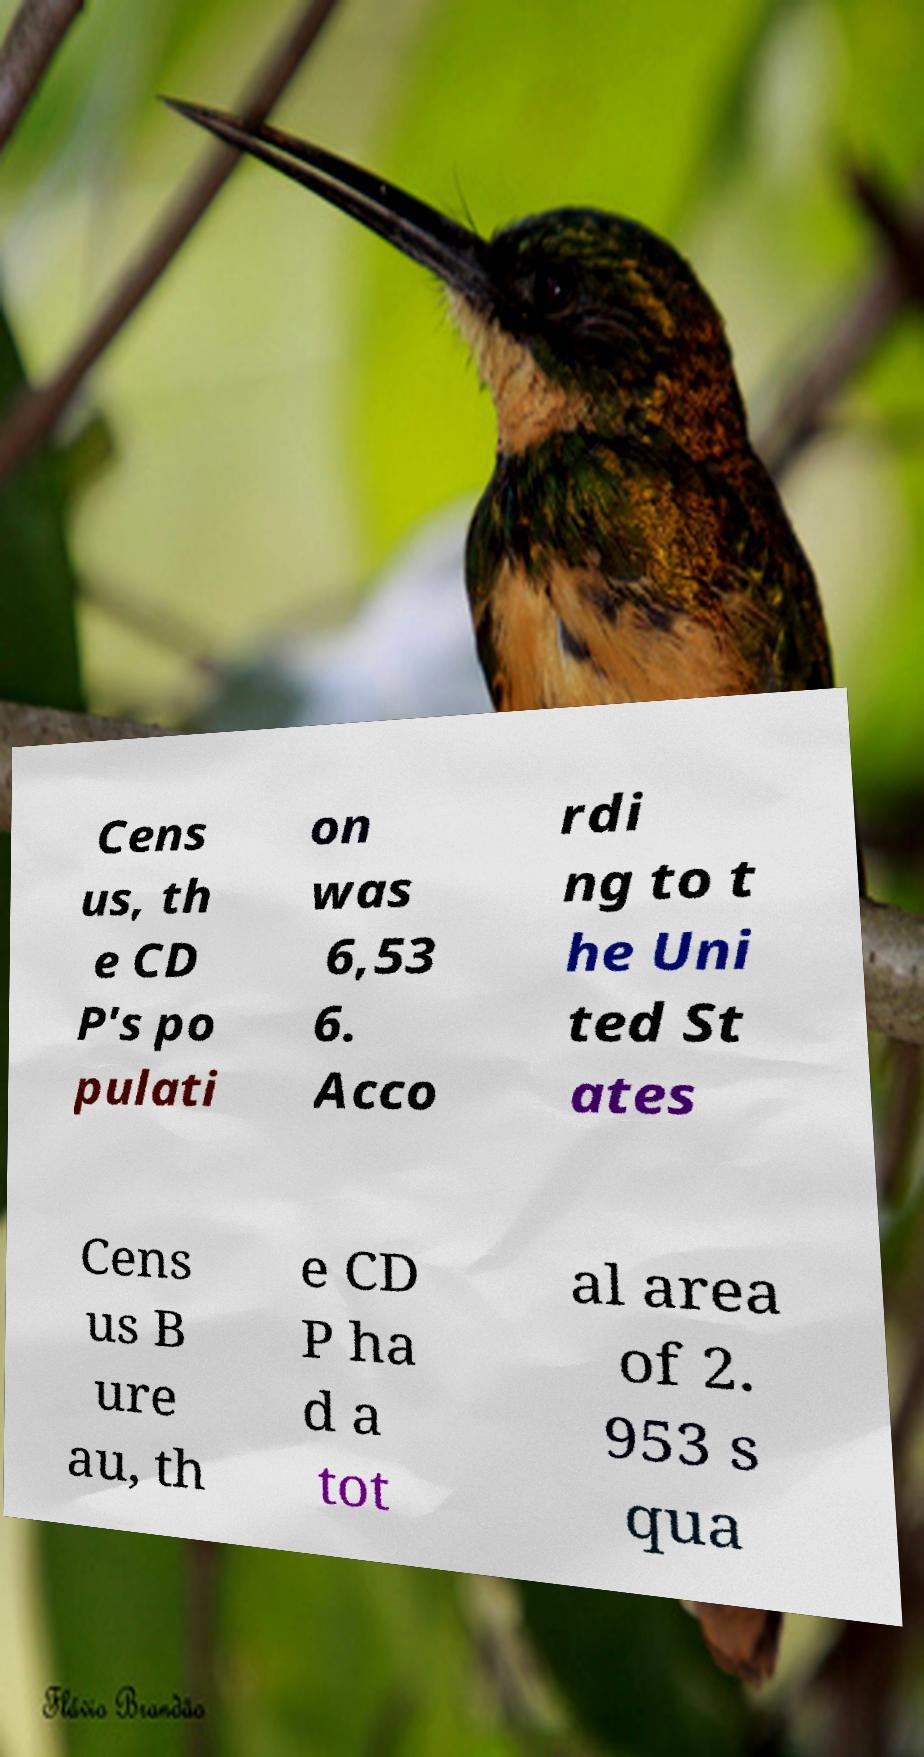What messages or text are displayed in this image? I need them in a readable, typed format. Cens us, th e CD P's po pulati on was 6,53 6. Acco rdi ng to t he Uni ted St ates Cens us B ure au, th e CD P ha d a tot al area of 2. 953 s qua 